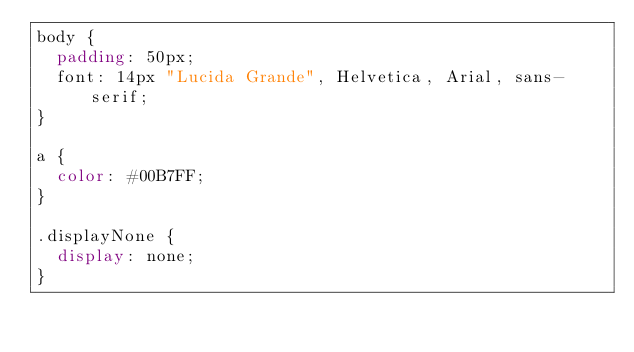Convert code to text. <code><loc_0><loc_0><loc_500><loc_500><_CSS_>body {
  padding: 50px;
  font: 14px "Lucida Grande", Helvetica, Arial, sans-serif;
}

a {
  color: #00B7FF;
}

.displayNone {
  display: none;
}</code> 